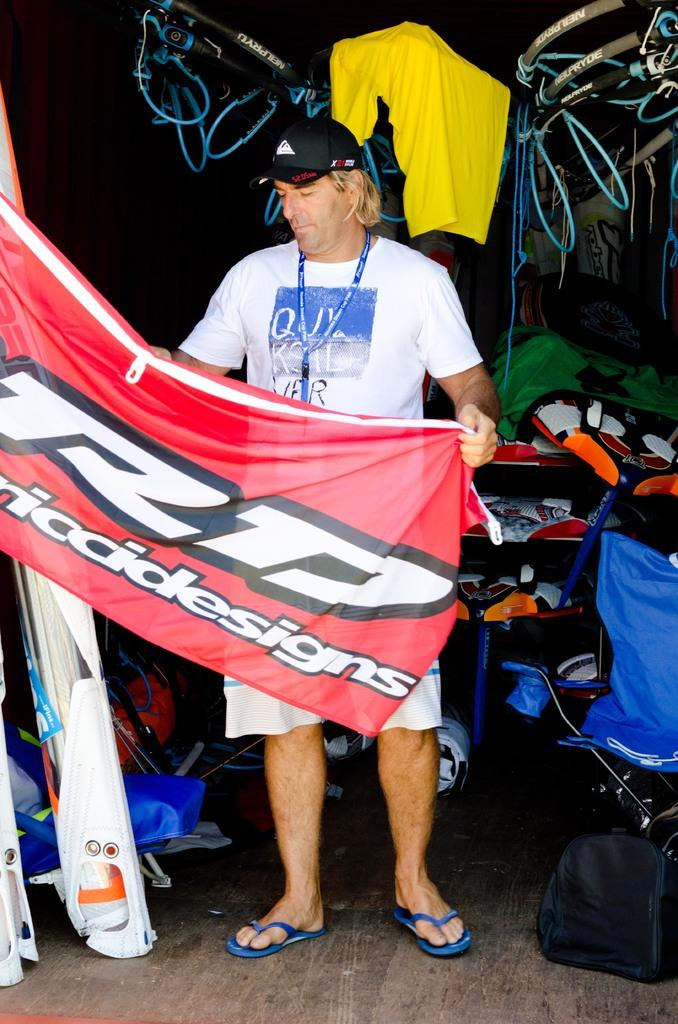<image>
Present a compact description of the photo's key features. A man, wearing a white Quiksilver shirt, holds a red banner. 